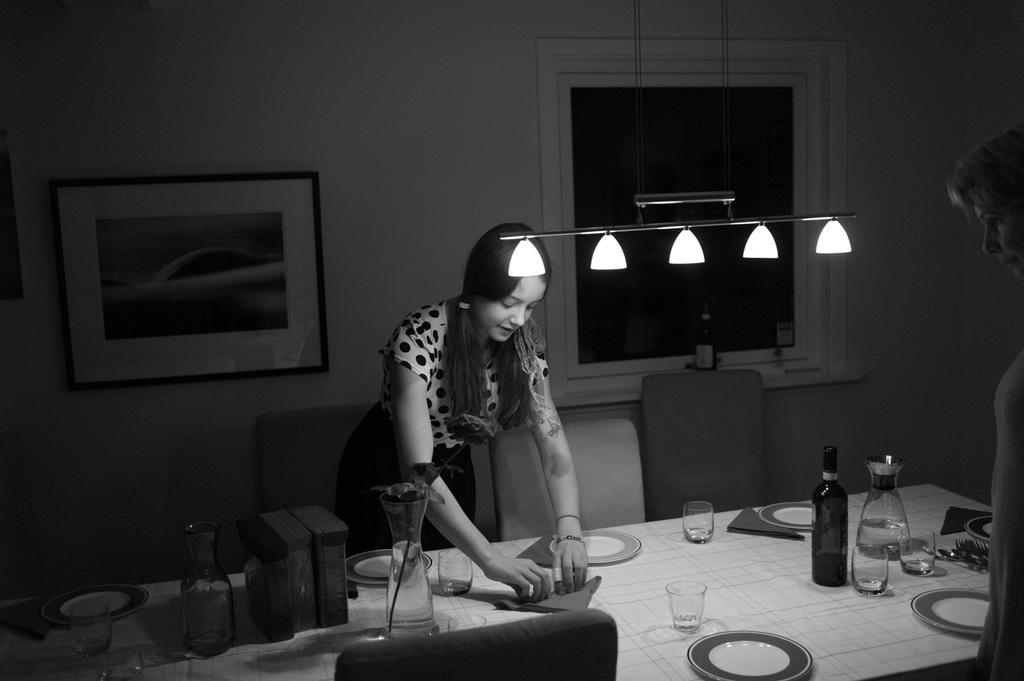Can you describe this image briefly? This is a black and white picture. Here we can see a woman. This is table. On the table there are plates, bottles, and glasses. These are the chairs. On the background there is a wall and this is frame. And there are lights. 